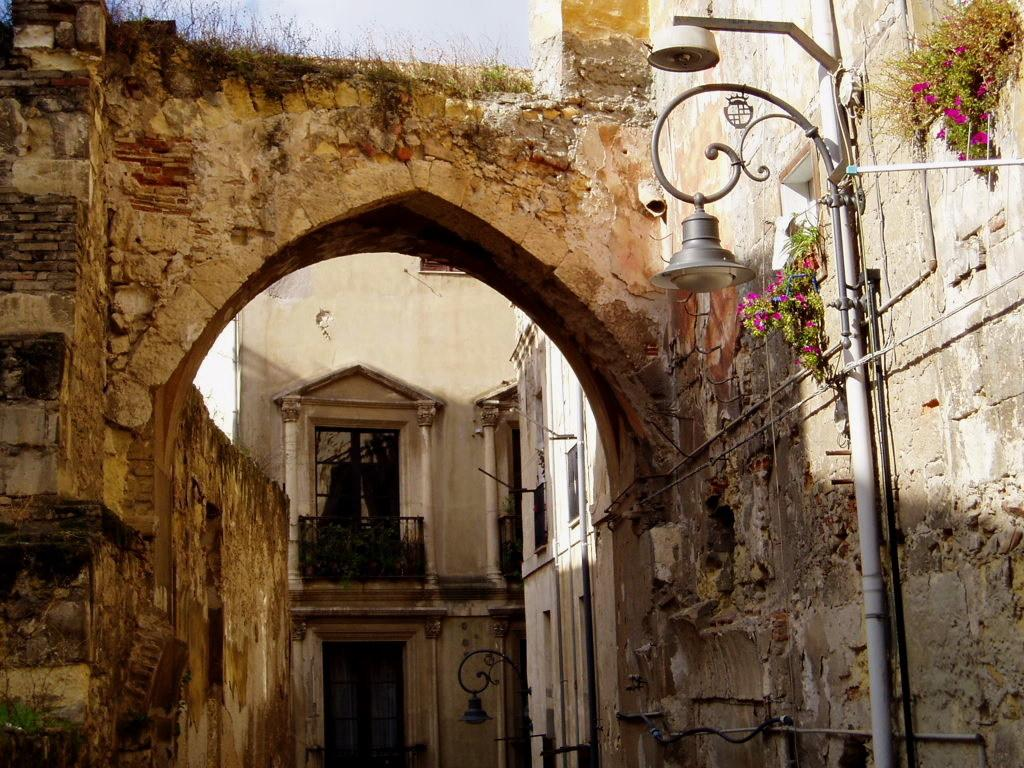What type of structure can be seen in the image? There is an arch and a building in the image. What type of feature is present along the sides of the arch? Railings are present in the image. What type of vegetation is visible in the image? Plants and creeper plants are present in the image. What type of urban infrastructure can be seen in the image? Street poles and street lights are in the image. What type of music is the girl playing on the nut in the image? There is no girl or nut present in the image, and therefore no such activity can be observed. 